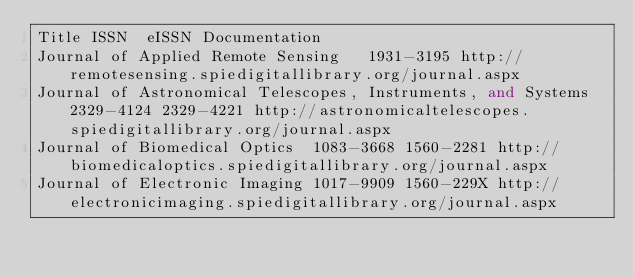<code> <loc_0><loc_0><loc_500><loc_500><_SQL_>Title	ISSN	eISSN	Documentation
Journal of Applied Remote Sensing		1931-3195	http://remotesensing.spiedigitallibrary.org/journal.aspx
Journal of Astronomical Telescopes, Instruments, and Systems	2329-4124	2329-4221	http://astronomicaltelescopes.spiedigitallibrary.org/journal.aspx
Journal of Biomedical Optics	1083-3668	1560-2281	http://biomedicaloptics.spiedigitallibrary.org/journal.aspx
Journal of Electronic Imaging	1017-9909	1560-229X	http://electronicimaging.spiedigitallibrary.org/journal.aspx</code> 